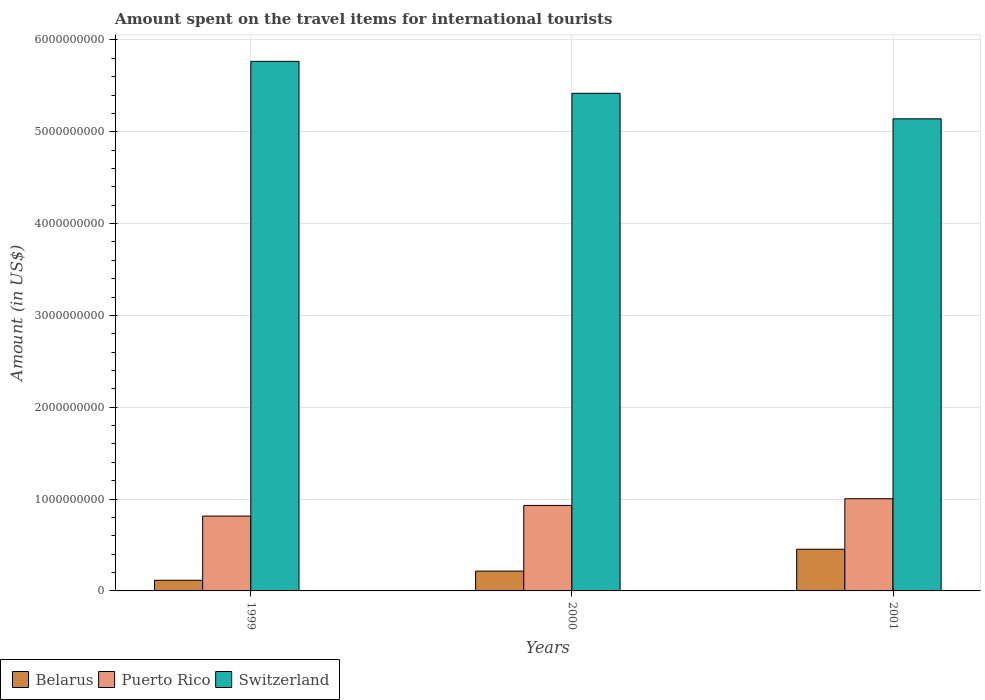How many groups of bars are there?
Provide a short and direct response. 3. Are the number of bars per tick equal to the number of legend labels?
Make the answer very short. Yes. Are the number of bars on each tick of the X-axis equal?
Keep it short and to the point. Yes. How many bars are there on the 3rd tick from the right?
Your response must be concise. 3. What is the amount spent on the travel items for international tourists in Puerto Rico in 2001?
Your answer should be compact. 1.00e+09. Across all years, what is the maximum amount spent on the travel items for international tourists in Switzerland?
Ensure brevity in your answer.  5.77e+09. Across all years, what is the minimum amount spent on the travel items for international tourists in Puerto Rico?
Provide a succinct answer. 8.15e+08. In which year was the amount spent on the travel items for international tourists in Belarus maximum?
Provide a short and direct response. 2001. In which year was the amount spent on the travel items for international tourists in Belarus minimum?
Ensure brevity in your answer.  1999. What is the total amount spent on the travel items for international tourists in Puerto Rico in the graph?
Ensure brevity in your answer.  2.75e+09. What is the difference between the amount spent on the travel items for international tourists in Puerto Rico in 1999 and that in 2000?
Provide a short and direct response. -1.16e+08. What is the difference between the amount spent on the travel items for international tourists in Puerto Rico in 2000 and the amount spent on the travel items for international tourists in Belarus in 1999?
Offer a very short reply. 8.15e+08. What is the average amount spent on the travel items for international tourists in Puerto Rico per year?
Offer a very short reply. 9.17e+08. In the year 1999, what is the difference between the amount spent on the travel items for international tourists in Puerto Rico and amount spent on the travel items for international tourists in Switzerland?
Keep it short and to the point. -4.95e+09. In how many years, is the amount spent on the travel items for international tourists in Switzerland greater than 3200000000 US$?
Your response must be concise. 3. What is the ratio of the amount spent on the travel items for international tourists in Belarus in 1999 to that in 2000?
Offer a terse response. 0.54. Is the amount spent on the travel items for international tourists in Switzerland in 2000 less than that in 2001?
Provide a succinct answer. No. Is the difference between the amount spent on the travel items for international tourists in Puerto Rico in 2000 and 2001 greater than the difference between the amount spent on the travel items for international tourists in Switzerland in 2000 and 2001?
Provide a succinct answer. No. What is the difference between the highest and the second highest amount spent on the travel items for international tourists in Switzerland?
Make the answer very short. 3.48e+08. What is the difference between the highest and the lowest amount spent on the travel items for international tourists in Puerto Rico?
Your answer should be compact. 1.89e+08. In how many years, is the amount spent on the travel items for international tourists in Belarus greater than the average amount spent on the travel items for international tourists in Belarus taken over all years?
Offer a terse response. 1. Is the sum of the amount spent on the travel items for international tourists in Puerto Rico in 1999 and 2000 greater than the maximum amount spent on the travel items for international tourists in Belarus across all years?
Provide a short and direct response. Yes. What does the 3rd bar from the left in 2001 represents?
Your answer should be compact. Switzerland. What does the 1st bar from the right in 2000 represents?
Your response must be concise. Switzerland. Is it the case that in every year, the sum of the amount spent on the travel items for international tourists in Switzerland and amount spent on the travel items for international tourists in Belarus is greater than the amount spent on the travel items for international tourists in Puerto Rico?
Provide a succinct answer. Yes. Are all the bars in the graph horizontal?
Offer a terse response. No. How many years are there in the graph?
Offer a terse response. 3. What is the difference between two consecutive major ticks on the Y-axis?
Offer a very short reply. 1.00e+09. Does the graph contain any zero values?
Your answer should be very brief. No. Does the graph contain grids?
Ensure brevity in your answer.  Yes. Where does the legend appear in the graph?
Your answer should be very brief. Bottom left. How many legend labels are there?
Provide a succinct answer. 3. What is the title of the graph?
Your answer should be compact. Amount spent on the travel items for international tourists. What is the label or title of the X-axis?
Provide a short and direct response. Years. What is the label or title of the Y-axis?
Give a very brief answer. Amount (in US$). What is the Amount (in US$) of Belarus in 1999?
Provide a succinct answer. 1.16e+08. What is the Amount (in US$) in Puerto Rico in 1999?
Provide a short and direct response. 8.15e+08. What is the Amount (in US$) of Switzerland in 1999?
Provide a succinct answer. 5.77e+09. What is the Amount (in US$) of Belarus in 2000?
Keep it short and to the point. 2.16e+08. What is the Amount (in US$) of Puerto Rico in 2000?
Offer a terse response. 9.31e+08. What is the Amount (in US$) of Switzerland in 2000?
Offer a terse response. 5.42e+09. What is the Amount (in US$) in Belarus in 2001?
Your answer should be compact. 4.54e+08. What is the Amount (in US$) in Puerto Rico in 2001?
Your answer should be very brief. 1.00e+09. What is the Amount (in US$) in Switzerland in 2001?
Provide a short and direct response. 5.14e+09. Across all years, what is the maximum Amount (in US$) of Belarus?
Provide a short and direct response. 4.54e+08. Across all years, what is the maximum Amount (in US$) in Puerto Rico?
Give a very brief answer. 1.00e+09. Across all years, what is the maximum Amount (in US$) in Switzerland?
Ensure brevity in your answer.  5.77e+09. Across all years, what is the minimum Amount (in US$) of Belarus?
Make the answer very short. 1.16e+08. Across all years, what is the minimum Amount (in US$) of Puerto Rico?
Keep it short and to the point. 8.15e+08. Across all years, what is the minimum Amount (in US$) in Switzerland?
Make the answer very short. 5.14e+09. What is the total Amount (in US$) in Belarus in the graph?
Offer a terse response. 7.86e+08. What is the total Amount (in US$) in Puerto Rico in the graph?
Provide a succinct answer. 2.75e+09. What is the total Amount (in US$) in Switzerland in the graph?
Ensure brevity in your answer.  1.63e+1. What is the difference between the Amount (in US$) of Belarus in 1999 and that in 2000?
Keep it short and to the point. -1.00e+08. What is the difference between the Amount (in US$) of Puerto Rico in 1999 and that in 2000?
Keep it short and to the point. -1.16e+08. What is the difference between the Amount (in US$) of Switzerland in 1999 and that in 2000?
Provide a succinct answer. 3.48e+08. What is the difference between the Amount (in US$) in Belarus in 1999 and that in 2001?
Make the answer very short. -3.38e+08. What is the difference between the Amount (in US$) of Puerto Rico in 1999 and that in 2001?
Ensure brevity in your answer.  -1.89e+08. What is the difference between the Amount (in US$) of Switzerland in 1999 and that in 2001?
Offer a very short reply. 6.26e+08. What is the difference between the Amount (in US$) of Belarus in 2000 and that in 2001?
Ensure brevity in your answer.  -2.38e+08. What is the difference between the Amount (in US$) of Puerto Rico in 2000 and that in 2001?
Provide a short and direct response. -7.30e+07. What is the difference between the Amount (in US$) of Switzerland in 2000 and that in 2001?
Make the answer very short. 2.78e+08. What is the difference between the Amount (in US$) of Belarus in 1999 and the Amount (in US$) of Puerto Rico in 2000?
Provide a succinct answer. -8.15e+08. What is the difference between the Amount (in US$) of Belarus in 1999 and the Amount (in US$) of Switzerland in 2000?
Your response must be concise. -5.30e+09. What is the difference between the Amount (in US$) of Puerto Rico in 1999 and the Amount (in US$) of Switzerland in 2000?
Keep it short and to the point. -4.60e+09. What is the difference between the Amount (in US$) in Belarus in 1999 and the Amount (in US$) in Puerto Rico in 2001?
Your answer should be compact. -8.88e+08. What is the difference between the Amount (in US$) in Belarus in 1999 and the Amount (in US$) in Switzerland in 2001?
Keep it short and to the point. -5.02e+09. What is the difference between the Amount (in US$) in Puerto Rico in 1999 and the Amount (in US$) in Switzerland in 2001?
Make the answer very short. -4.33e+09. What is the difference between the Amount (in US$) of Belarus in 2000 and the Amount (in US$) of Puerto Rico in 2001?
Give a very brief answer. -7.88e+08. What is the difference between the Amount (in US$) in Belarus in 2000 and the Amount (in US$) in Switzerland in 2001?
Your answer should be compact. -4.92e+09. What is the difference between the Amount (in US$) in Puerto Rico in 2000 and the Amount (in US$) in Switzerland in 2001?
Provide a succinct answer. -4.21e+09. What is the average Amount (in US$) of Belarus per year?
Ensure brevity in your answer.  2.62e+08. What is the average Amount (in US$) in Puerto Rico per year?
Make the answer very short. 9.17e+08. What is the average Amount (in US$) in Switzerland per year?
Offer a terse response. 5.44e+09. In the year 1999, what is the difference between the Amount (in US$) of Belarus and Amount (in US$) of Puerto Rico?
Offer a terse response. -6.99e+08. In the year 1999, what is the difference between the Amount (in US$) of Belarus and Amount (in US$) of Switzerland?
Your answer should be compact. -5.65e+09. In the year 1999, what is the difference between the Amount (in US$) of Puerto Rico and Amount (in US$) of Switzerland?
Make the answer very short. -4.95e+09. In the year 2000, what is the difference between the Amount (in US$) in Belarus and Amount (in US$) in Puerto Rico?
Provide a short and direct response. -7.15e+08. In the year 2000, what is the difference between the Amount (in US$) of Belarus and Amount (in US$) of Switzerland?
Provide a short and direct response. -5.20e+09. In the year 2000, what is the difference between the Amount (in US$) of Puerto Rico and Amount (in US$) of Switzerland?
Offer a very short reply. -4.49e+09. In the year 2001, what is the difference between the Amount (in US$) in Belarus and Amount (in US$) in Puerto Rico?
Your answer should be compact. -5.50e+08. In the year 2001, what is the difference between the Amount (in US$) of Belarus and Amount (in US$) of Switzerland?
Keep it short and to the point. -4.69e+09. In the year 2001, what is the difference between the Amount (in US$) in Puerto Rico and Amount (in US$) in Switzerland?
Offer a very short reply. -4.14e+09. What is the ratio of the Amount (in US$) of Belarus in 1999 to that in 2000?
Your answer should be very brief. 0.54. What is the ratio of the Amount (in US$) in Puerto Rico in 1999 to that in 2000?
Provide a short and direct response. 0.88. What is the ratio of the Amount (in US$) in Switzerland in 1999 to that in 2000?
Ensure brevity in your answer.  1.06. What is the ratio of the Amount (in US$) of Belarus in 1999 to that in 2001?
Keep it short and to the point. 0.26. What is the ratio of the Amount (in US$) in Puerto Rico in 1999 to that in 2001?
Make the answer very short. 0.81. What is the ratio of the Amount (in US$) in Switzerland in 1999 to that in 2001?
Provide a short and direct response. 1.12. What is the ratio of the Amount (in US$) of Belarus in 2000 to that in 2001?
Keep it short and to the point. 0.48. What is the ratio of the Amount (in US$) of Puerto Rico in 2000 to that in 2001?
Offer a terse response. 0.93. What is the ratio of the Amount (in US$) of Switzerland in 2000 to that in 2001?
Your answer should be very brief. 1.05. What is the difference between the highest and the second highest Amount (in US$) of Belarus?
Your answer should be very brief. 2.38e+08. What is the difference between the highest and the second highest Amount (in US$) of Puerto Rico?
Your answer should be compact. 7.30e+07. What is the difference between the highest and the second highest Amount (in US$) of Switzerland?
Provide a succinct answer. 3.48e+08. What is the difference between the highest and the lowest Amount (in US$) of Belarus?
Offer a very short reply. 3.38e+08. What is the difference between the highest and the lowest Amount (in US$) of Puerto Rico?
Give a very brief answer. 1.89e+08. What is the difference between the highest and the lowest Amount (in US$) in Switzerland?
Keep it short and to the point. 6.26e+08. 